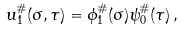<formula> <loc_0><loc_0><loc_500><loc_500>u _ { 1 } ^ { \# } ( \sigma , \tau ) = \phi _ { 1 } ^ { \# } ( \sigma ) \psi _ { 0 } ^ { \# } ( \tau ) \, ,</formula> 